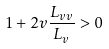<formula> <loc_0><loc_0><loc_500><loc_500>1 + 2 v \frac { L _ { v v } } { L _ { v } } > 0</formula> 